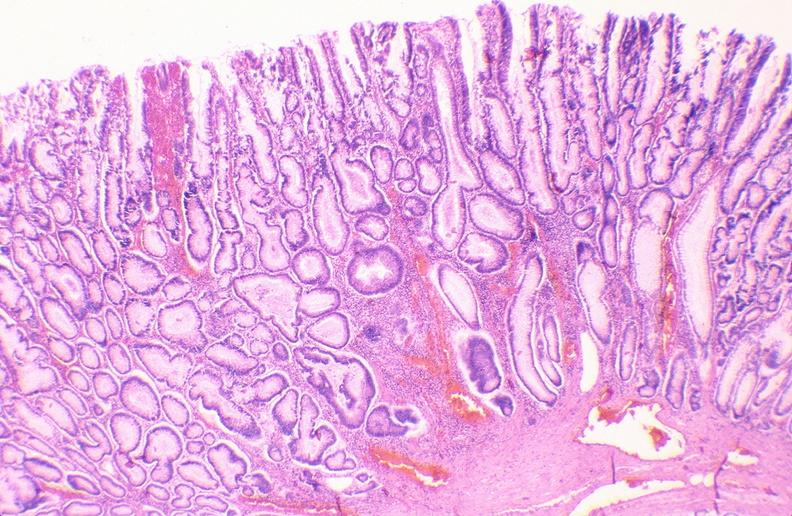what is present?
Answer the question using a single word or phrase. Gastrointestinal 